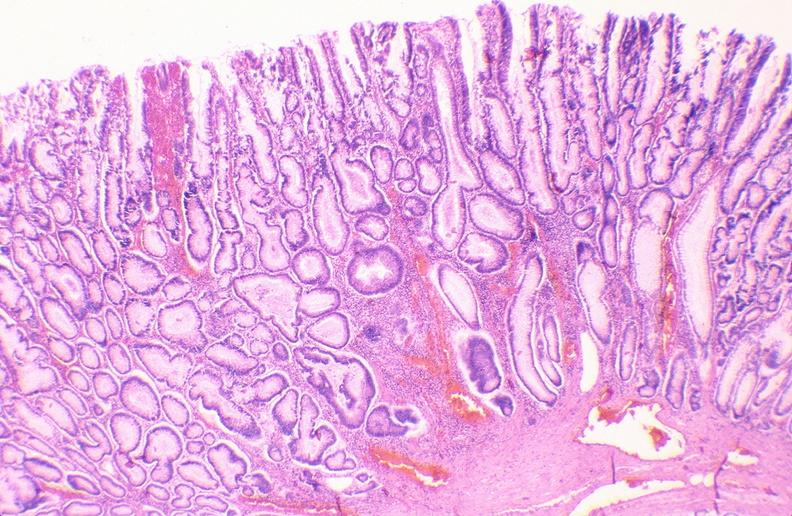what is present?
Answer the question using a single word or phrase. Gastrointestinal 